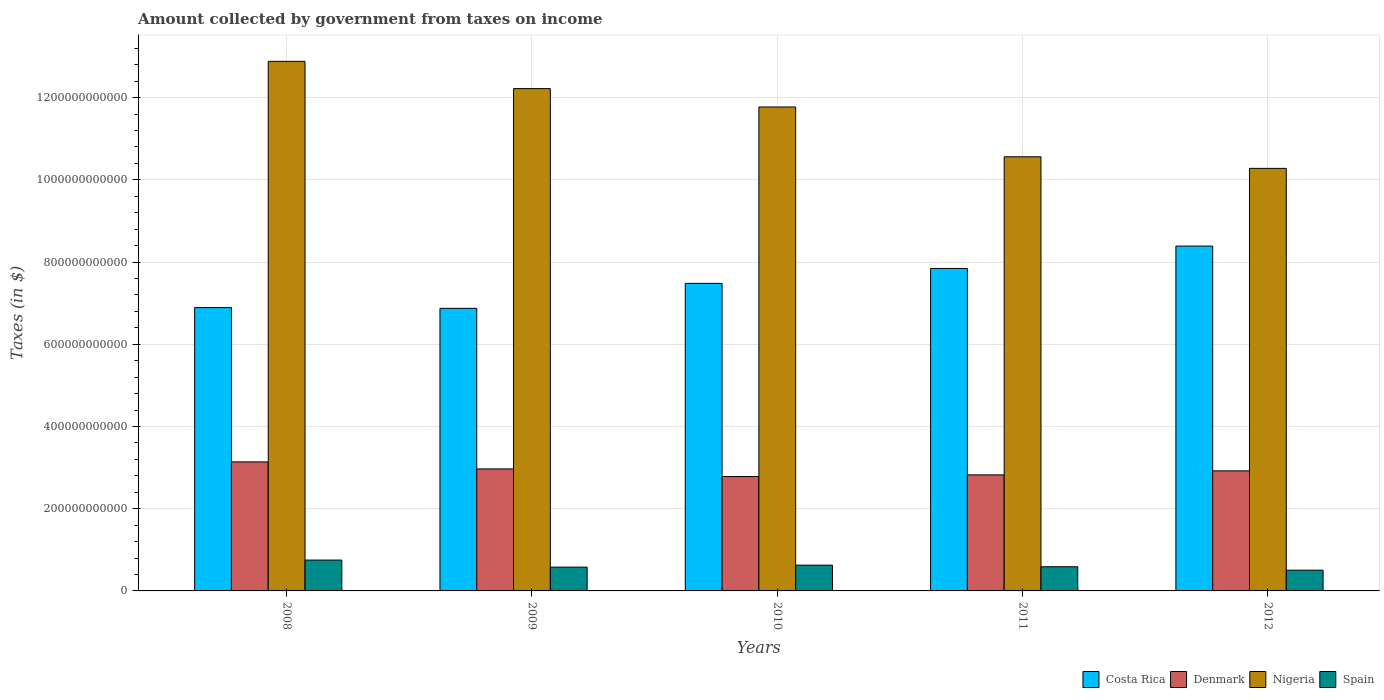How many different coloured bars are there?
Make the answer very short. 4. How many groups of bars are there?
Offer a very short reply. 5. Are the number of bars per tick equal to the number of legend labels?
Make the answer very short. Yes. Are the number of bars on each tick of the X-axis equal?
Your answer should be very brief. Yes. How many bars are there on the 1st tick from the right?
Provide a short and direct response. 4. What is the amount collected by government from taxes on income in Nigeria in 2011?
Make the answer very short. 1.06e+12. Across all years, what is the maximum amount collected by government from taxes on income in Spain?
Provide a succinct answer. 7.50e+1. Across all years, what is the minimum amount collected by government from taxes on income in Nigeria?
Make the answer very short. 1.03e+12. What is the total amount collected by government from taxes on income in Spain in the graph?
Provide a short and direct response. 3.05e+11. What is the difference between the amount collected by government from taxes on income in Nigeria in 2010 and that in 2012?
Your response must be concise. 1.49e+11. What is the difference between the amount collected by government from taxes on income in Denmark in 2008 and the amount collected by government from taxes on income in Spain in 2012?
Ensure brevity in your answer.  2.63e+11. What is the average amount collected by government from taxes on income in Spain per year?
Provide a short and direct response. 6.10e+1. In the year 2012, what is the difference between the amount collected by government from taxes on income in Costa Rica and amount collected by government from taxes on income in Denmark?
Give a very brief answer. 5.47e+11. What is the ratio of the amount collected by government from taxes on income in Nigeria in 2008 to that in 2011?
Offer a terse response. 1.22. Is the amount collected by government from taxes on income in Denmark in 2010 less than that in 2011?
Offer a very short reply. Yes. Is the difference between the amount collected by government from taxes on income in Costa Rica in 2011 and 2012 greater than the difference between the amount collected by government from taxes on income in Denmark in 2011 and 2012?
Make the answer very short. No. What is the difference between the highest and the second highest amount collected by government from taxes on income in Nigeria?
Your answer should be very brief. 6.63e+1. What is the difference between the highest and the lowest amount collected by government from taxes on income in Nigeria?
Keep it short and to the point. 2.60e+11. What does the 3rd bar from the left in 2012 represents?
Give a very brief answer. Nigeria. What does the 3rd bar from the right in 2010 represents?
Give a very brief answer. Denmark. Is it the case that in every year, the sum of the amount collected by government from taxes on income in Nigeria and amount collected by government from taxes on income in Spain is greater than the amount collected by government from taxes on income in Costa Rica?
Provide a succinct answer. Yes. What is the difference between two consecutive major ticks on the Y-axis?
Keep it short and to the point. 2.00e+11. Where does the legend appear in the graph?
Make the answer very short. Bottom right. How many legend labels are there?
Make the answer very short. 4. How are the legend labels stacked?
Make the answer very short. Horizontal. What is the title of the graph?
Offer a very short reply. Amount collected by government from taxes on income. What is the label or title of the X-axis?
Ensure brevity in your answer.  Years. What is the label or title of the Y-axis?
Your answer should be compact. Taxes (in $). What is the Taxes (in $) of Costa Rica in 2008?
Keep it short and to the point. 6.89e+11. What is the Taxes (in $) of Denmark in 2008?
Give a very brief answer. 3.14e+11. What is the Taxes (in $) in Nigeria in 2008?
Keep it short and to the point. 1.29e+12. What is the Taxes (in $) of Spain in 2008?
Provide a short and direct response. 7.50e+1. What is the Taxes (in $) in Costa Rica in 2009?
Your answer should be compact. 6.87e+11. What is the Taxes (in $) of Denmark in 2009?
Your response must be concise. 2.97e+11. What is the Taxes (in $) of Nigeria in 2009?
Give a very brief answer. 1.22e+12. What is the Taxes (in $) of Spain in 2009?
Keep it short and to the point. 5.79e+1. What is the Taxes (in $) of Costa Rica in 2010?
Keep it short and to the point. 7.48e+11. What is the Taxes (in $) in Denmark in 2010?
Your answer should be compact. 2.78e+11. What is the Taxes (in $) of Nigeria in 2010?
Your answer should be very brief. 1.18e+12. What is the Taxes (in $) in Spain in 2010?
Give a very brief answer. 6.27e+1. What is the Taxes (in $) of Costa Rica in 2011?
Your response must be concise. 7.84e+11. What is the Taxes (in $) of Denmark in 2011?
Provide a short and direct response. 2.82e+11. What is the Taxes (in $) in Nigeria in 2011?
Offer a very short reply. 1.06e+12. What is the Taxes (in $) of Spain in 2011?
Your answer should be very brief. 5.88e+1. What is the Taxes (in $) in Costa Rica in 2012?
Offer a very short reply. 8.39e+11. What is the Taxes (in $) in Denmark in 2012?
Provide a short and direct response. 2.92e+11. What is the Taxes (in $) of Nigeria in 2012?
Give a very brief answer. 1.03e+12. What is the Taxes (in $) in Spain in 2012?
Keep it short and to the point. 5.05e+1. Across all years, what is the maximum Taxes (in $) in Costa Rica?
Provide a succinct answer. 8.39e+11. Across all years, what is the maximum Taxes (in $) in Denmark?
Your response must be concise. 3.14e+11. Across all years, what is the maximum Taxes (in $) of Nigeria?
Your response must be concise. 1.29e+12. Across all years, what is the maximum Taxes (in $) in Spain?
Your answer should be compact. 7.50e+1. Across all years, what is the minimum Taxes (in $) in Costa Rica?
Your response must be concise. 6.87e+11. Across all years, what is the minimum Taxes (in $) in Denmark?
Ensure brevity in your answer.  2.78e+11. Across all years, what is the minimum Taxes (in $) of Nigeria?
Offer a very short reply. 1.03e+12. Across all years, what is the minimum Taxes (in $) in Spain?
Ensure brevity in your answer.  5.05e+1. What is the total Taxes (in $) of Costa Rica in the graph?
Keep it short and to the point. 3.75e+12. What is the total Taxes (in $) of Denmark in the graph?
Ensure brevity in your answer.  1.46e+12. What is the total Taxes (in $) in Nigeria in the graph?
Offer a terse response. 5.77e+12. What is the total Taxes (in $) in Spain in the graph?
Your answer should be compact. 3.05e+11. What is the difference between the Taxes (in $) in Costa Rica in 2008 and that in 2009?
Keep it short and to the point. 1.80e+09. What is the difference between the Taxes (in $) in Denmark in 2008 and that in 2009?
Make the answer very short. 1.71e+1. What is the difference between the Taxes (in $) in Nigeria in 2008 and that in 2009?
Provide a short and direct response. 6.63e+1. What is the difference between the Taxes (in $) in Spain in 2008 and that in 2009?
Your response must be concise. 1.71e+1. What is the difference between the Taxes (in $) of Costa Rica in 2008 and that in 2010?
Provide a short and direct response. -5.89e+1. What is the difference between the Taxes (in $) of Denmark in 2008 and that in 2010?
Provide a short and direct response. 3.56e+1. What is the difference between the Taxes (in $) of Nigeria in 2008 and that in 2010?
Your answer should be compact. 1.11e+11. What is the difference between the Taxes (in $) of Spain in 2008 and that in 2010?
Your answer should be very brief. 1.23e+1. What is the difference between the Taxes (in $) of Costa Rica in 2008 and that in 2011?
Ensure brevity in your answer.  -9.52e+1. What is the difference between the Taxes (in $) in Denmark in 2008 and that in 2011?
Keep it short and to the point. 3.16e+1. What is the difference between the Taxes (in $) in Nigeria in 2008 and that in 2011?
Ensure brevity in your answer.  2.32e+11. What is the difference between the Taxes (in $) of Spain in 2008 and that in 2011?
Offer a very short reply. 1.62e+1. What is the difference between the Taxes (in $) of Costa Rica in 2008 and that in 2012?
Keep it short and to the point. -1.50e+11. What is the difference between the Taxes (in $) in Denmark in 2008 and that in 2012?
Your answer should be very brief. 2.18e+1. What is the difference between the Taxes (in $) in Nigeria in 2008 and that in 2012?
Give a very brief answer. 2.60e+11. What is the difference between the Taxes (in $) of Spain in 2008 and that in 2012?
Ensure brevity in your answer.  2.46e+1. What is the difference between the Taxes (in $) of Costa Rica in 2009 and that in 2010?
Your answer should be compact. -6.07e+1. What is the difference between the Taxes (in $) in Denmark in 2009 and that in 2010?
Your answer should be very brief. 1.85e+1. What is the difference between the Taxes (in $) in Nigeria in 2009 and that in 2010?
Your answer should be compact. 4.47e+1. What is the difference between the Taxes (in $) in Spain in 2009 and that in 2010?
Make the answer very short. -4.79e+09. What is the difference between the Taxes (in $) of Costa Rica in 2009 and that in 2011?
Provide a succinct answer. -9.70e+1. What is the difference between the Taxes (in $) in Denmark in 2009 and that in 2011?
Keep it short and to the point. 1.45e+1. What is the difference between the Taxes (in $) of Nigeria in 2009 and that in 2011?
Your response must be concise. 1.66e+11. What is the difference between the Taxes (in $) in Spain in 2009 and that in 2011?
Ensure brevity in your answer.  -8.93e+08. What is the difference between the Taxes (in $) in Costa Rica in 2009 and that in 2012?
Make the answer very short. -1.51e+11. What is the difference between the Taxes (in $) of Denmark in 2009 and that in 2012?
Make the answer very short. 4.66e+09. What is the difference between the Taxes (in $) of Nigeria in 2009 and that in 2012?
Your answer should be very brief. 1.94e+11. What is the difference between the Taxes (in $) in Spain in 2009 and that in 2012?
Provide a short and direct response. 7.44e+09. What is the difference between the Taxes (in $) of Costa Rica in 2010 and that in 2011?
Offer a terse response. -3.63e+1. What is the difference between the Taxes (in $) of Denmark in 2010 and that in 2011?
Ensure brevity in your answer.  -4.02e+09. What is the difference between the Taxes (in $) in Nigeria in 2010 and that in 2011?
Provide a short and direct response. 1.21e+11. What is the difference between the Taxes (in $) in Spain in 2010 and that in 2011?
Ensure brevity in your answer.  3.90e+09. What is the difference between the Taxes (in $) of Costa Rica in 2010 and that in 2012?
Provide a short and direct response. -9.07e+1. What is the difference between the Taxes (in $) in Denmark in 2010 and that in 2012?
Provide a succinct answer. -1.39e+1. What is the difference between the Taxes (in $) of Nigeria in 2010 and that in 2012?
Keep it short and to the point. 1.49e+11. What is the difference between the Taxes (in $) in Spain in 2010 and that in 2012?
Provide a short and direct response. 1.22e+1. What is the difference between the Taxes (in $) in Costa Rica in 2011 and that in 2012?
Provide a succinct answer. -5.44e+1. What is the difference between the Taxes (in $) of Denmark in 2011 and that in 2012?
Ensure brevity in your answer.  -9.83e+09. What is the difference between the Taxes (in $) in Nigeria in 2011 and that in 2012?
Provide a succinct answer. 2.82e+1. What is the difference between the Taxes (in $) in Spain in 2011 and that in 2012?
Give a very brief answer. 8.33e+09. What is the difference between the Taxes (in $) of Costa Rica in 2008 and the Taxes (in $) of Denmark in 2009?
Your response must be concise. 3.92e+11. What is the difference between the Taxes (in $) in Costa Rica in 2008 and the Taxes (in $) in Nigeria in 2009?
Ensure brevity in your answer.  -5.33e+11. What is the difference between the Taxes (in $) of Costa Rica in 2008 and the Taxes (in $) of Spain in 2009?
Offer a very short reply. 6.31e+11. What is the difference between the Taxes (in $) of Denmark in 2008 and the Taxes (in $) of Nigeria in 2009?
Keep it short and to the point. -9.08e+11. What is the difference between the Taxes (in $) of Denmark in 2008 and the Taxes (in $) of Spain in 2009?
Your answer should be very brief. 2.56e+11. What is the difference between the Taxes (in $) in Nigeria in 2008 and the Taxes (in $) in Spain in 2009?
Your answer should be very brief. 1.23e+12. What is the difference between the Taxes (in $) of Costa Rica in 2008 and the Taxes (in $) of Denmark in 2010?
Provide a succinct answer. 4.11e+11. What is the difference between the Taxes (in $) of Costa Rica in 2008 and the Taxes (in $) of Nigeria in 2010?
Provide a succinct answer. -4.88e+11. What is the difference between the Taxes (in $) of Costa Rica in 2008 and the Taxes (in $) of Spain in 2010?
Your answer should be compact. 6.27e+11. What is the difference between the Taxes (in $) in Denmark in 2008 and the Taxes (in $) in Nigeria in 2010?
Provide a succinct answer. -8.63e+11. What is the difference between the Taxes (in $) of Denmark in 2008 and the Taxes (in $) of Spain in 2010?
Provide a short and direct response. 2.51e+11. What is the difference between the Taxes (in $) of Nigeria in 2008 and the Taxes (in $) of Spain in 2010?
Offer a very short reply. 1.23e+12. What is the difference between the Taxes (in $) in Costa Rica in 2008 and the Taxes (in $) in Denmark in 2011?
Offer a very short reply. 4.07e+11. What is the difference between the Taxes (in $) in Costa Rica in 2008 and the Taxes (in $) in Nigeria in 2011?
Offer a very short reply. -3.67e+11. What is the difference between the Taxes (in $) in Costa Rica in 2008 and the Taxes (in $) in Spain in 2011?
Your response must be concise. 6.30e+11. What is the difference between the Taxes (in $) of Denmark in 2008 and the Taxes (in $) of Nigeria in 2011?
Keep it short and to the point. -7.42e+11. What is the difference between the Taxes (in $) in Denmark in 2008 and the Taxes (in $) in Spain in 2011?
Your answer should be very brief. 2.55e+11. What is the difference between the Taxes (in $) in Nigeria in 2008 and the Taxes (in $) in Spain in 2011?
Give a very brief answer. 1.23e+12. What is the difference between the Taxes (in $) of Costa Rica in 2008 and the Taxes (in $) of Denmark in 2012?
Your answer should be very brief. 3.97e+11. What is the difference between the Taxes (in $) in Costa Rica in 2008 and the Taxes (in $) in Nigeria in 2012?
Your response must be concise. -3.39e+11. What is the difference between the Taxes (in $) in Costa Rica in 2008 and the Taxes (in $) in Spain in 2012?
Keep it short and to the point. 6.39e+11. What is the difference between the Taxes (in $) of Denmark in 2008 and the Taxes (in $) of Nigeria in 2012?
Keep it short and to the point. -7.14e+11. What is the difference between the Taxes (in $) in Denmark in 2008 and the Taxes (in $) in Spain in 2012?
Provide a short and direct response. 2.63e+11. What is the difference between the Taxes (in $) in Nigeria in 2008 and the Taxes (in $) in Spain in 2012?
Keep it short and to the point. 1.24e+12. What is the difference between the Taxes (in $) in Costa Rica in 2009 and the Taxes (in $) in Denmark in 2010?
Keep it short and to the point. 4.09e+11. What is the difference between the Taxes (in $) of Costa Rica in 2009 and the Taxes (in $) of Nigeria in 2010?
Your answer should be compact. -4.90e+11. What is the difference between the Taxes (in $) of Costa Rica in 2009 and the Taxes (in $) of Spain in 2010?
Offer a very short reply. 6.25e+11. What is the difference between the Taxes (in $) of Denmark in 2009 and the Taxes (in $) of Nigeria in 2010?
Offer a terse response. -8.80e+11. What is the difference between the Taxes (in $) in Denmark in 2009 and the Taxes (in $) in Spain in 2010?
Keep it short and to the point. 2.34e+11. What is the difference between the Taxes (in $) in Nigeria in 2009 and the Taxes (in $) in Spain in 2010?
Make the answer very short. 1.16e+12. What is the difference between the Taxes (in $) of Costa Rica in 2009 and the Taxes (in $) of Denmark in 2011?
Your answer should be compact. 4.05e+11. What is the difference between the Taxes (in $) of Costa Rica in 2009 and the Taxes (in $) of Nigeria in 2011?
Ensure brevity in your answer.  -3.69e+11. What is the difference between the Taxes (in $) in Costa Rica in 2009 and the Taxes (in $) in Spain in 2011?
Provide a short and direct response. 6.29e+11. What is the difference between the Taxes (in $) in Denmark in 2009 and the Taxes (in $) in Nigeria in 2011?
Provide a succinct answer. -7.59e+11. What is the difference between the Taxes (in $) of Denmark in 2009 and the Taxes (in $) of Spain in 2011?
Offer a very short reply. 2.38e+11. What is the difference between the Taxes (in $) in Nigeria in 2009 and the Taxes (in $) in Spain in 2011?
Provide a succinct answer. 1.16e+12. What is the difference between the Taxes (in $) in Costa Rica in 2009 and the Taxes (in $) in Denmark in 2012?
Your answer should be very brief. 3.95e+11. What is the difference between the Taxes (in $) in Costa Rica in 2009 and the Taxes (in $) in Nigeria in 2012?
Provide a succinct answer. -3.40e+11. What is the difference between the Taxes (in $) of Costa Rica in 2009 and the Taxes (in $) of Spain in 2012?
Your response must be concise. 6.37e+11. What is the difference between the Taxes (in $) in Denmark in 2009 and the Taxes (in $) in Nigeria in 2012?
Offer a terse response. -7.31e+11. What is the difference between the Taxes (in $) in Denmark in 2009 and the Taxes (in $) in Spain in 2012?
Provide a succinct answer. 2.46e+11. What is the difference between the Taxes (in $) of Nigeria in 2009 and the Taxes (in $) of Spain in 2012?
Keep it short and to the point. 1.17e+12. What is the difference between the Taxes (in $) in Costa Rica in 2010 and the Taxes (in $) in Denmark in 2011?
Your answer should be very brief. 4.66e+11. What is the difference between the Taxes (in $) of Costa Rica in 2010 and the Taxes (in $) of Nigeria in 2011?
Your response must be concise. -3.08e+11. What is the difference between the Taxes (in $) in Costa Rica in 2010 and the Taxes (in $) in Spain in 2011?
Provide a succinct answer. 6.89e+11. What is the difference between the Taxes (in $) of Denmark in 2010 and the Taxes (in $) of Nigeria in 2011?
Make the answer very short. -7.78e+11. What is the difference between the Taxes (in $) of Denmark in 2010 and the Taxes (in $) of Spain in 2011?
Give a very brief answer. 2.19e+11. What is the difference between the Taxes (in $) in Nigeria in 2010 and the Taxes (in $) in Spain in 2011?
Give a very brief answer. 1.12e+12. What is the difference between the Taxes (in $) of Costa Rica in 2010 and the Taxes (in $) of Denmark in 2012?
Your response must be concise. 4.56e+11. What is the difference between the Taxes (in $) in Costa Rica in 2010 and the Taxes (in $) in Nigeria in 2012?
Give a very brief answer. -2.80e+11. What is the difference between the Taxes (in $) in Costa Rica in 2010 and the Taxes (in $) in Spain in 2012?
Make the answer very short. 6.98e+11. What is the difference between the Taxes (in $) of Denmark in 2010 and the Taxes (in $) of Nigeria in 2012?
Provide a short and direct response. -7.50e+11. What is the difference between the Taxes (in $) of Denmark in 2010 and the Taxes (in $) of Spain in 2012?
Ensure brevity in your answer.  2.28e+11. What is the difference between the Taxes (in $) in Nigeria in 2010 and the Taxes (in $) in Spain in 2012?
Offer a very short reply. 1.13e+12. What is the difference between the Taxes (in $) of Costa Rica in 2011 and the Taxes (in $) of Denmark in 2012?
Provide a succinct answer. 4.92e+11. What is the difference between the Taxes (in $) of Costa Rica in 2011 and the Taxes (in $) of Nigeria in 2012?
Keep it short and to the point. -2.43e+11. What is the difference between the Taxes (in $) in Costa Rica in 2011 and the Taxes (in $) in Spain in 2012?
Ensure brevity in your answer.  7.34e+11. What is the difference between the Taxes (in $) in Denmark in 2011 and the Taxes (in $) in Nigeria in 2012?
Provide a succinct answer. -7.46e+11. What is the difference between the Taxes (in $) in Denmark in 2011 and the Taxes (in $) in Spain in 2012?
Give a very brief answer. 2.32e+11. What is the difference between the Taxes (in $) in Nigeria in 2011 and the Taxes (in $) in Spain in 2012?
Your answer should be very brief. 1.01e+12. What is the average Taxes (in $) in Costa Rica per year?
Provide a succinct answer. 7.50e+11. What is the average Taxes (in $) of Denmark per year?
Offer a very short reply. 2.93e+11. What is the average Taxes (in $) of Nigeria per year?
Your answer should be very brief. 1.15e+12. What is the average Taxes (in $) in Spain per year?
Provide a short and direct response. 6.10e+1. In the year 2008, what is the difference between the Taxes (in $) in Costa Rica and Taxes (in $) in Denmark?
Make the answer very short. 3.75e+11. In the year 2008, what is the difference between the Taxes (in $) in Costa Rica and Taxes (in $) in Nigeria?
Ensure brevity in your answer.  -5.99e+11. In the year 2008, what is the difference between the Taxes (in $) of Costa Rica and Taxes (in $) of Spain?
Your answer should be compact. 6.14e+11. In the year 2008, what is the difference between the Taxes (in $) in Denmark and Taxes (in $) in Nigeria?
Give a very brief answer. -9.74e+11. In the year 2008, what is the difference between the Taxes (in $) of Denmark and Taxes (in $) of Spain?
Offer a terse response. 2.39e+11. In the year 2008, what is the difference between the Taxes (in $) in Nigeria and Taxes (in $) in Spain?
Offer a very short reply. 1.21e+12. In the year 2009, what is the difference between the Taxes (in $) in Costa Rica and Taxes (in $) in Denmark?
Your answer should be very brief. 3.91e+11. In the year 2009, what is the difference between the Taxes (in $) in Costa Rica and Taxes (in $) in Nigeria?
Your response must be concise. -5.34e+11. In the year 2009, what is the difference between the Taxes (in $) of Costa Rica and Taxes (in $) of Spain?
Ensure brevity in your answer.  6.30e+11. In the year 2009, what is the difference between the Taxes (in $) in Denmark and Taxes (in $) in Nigeria?
Ensure brevity in your answer.  -9.25e+11. In the year 2009, what is the difference between the Taxes (in $) of Denmark and Taxes (in $) of Spain?
Make the answer very short. 2.39e+11. In the year 2009, what is the difference between the Taxes (in $) of Nigeria and Taxes (in $) of Spain?
Ensure brevity in your answer.  1.16e+12. In the year 2010, what is the difference between the Taxes (in $) in Costa Rica and Taxes (in $) in Denmark?
Ensure brevity in your answer.  4.70e+11. In the year 2010, what is the difference between the Taxes (in $) of Costa Rica and Taxes (in $) of Nigeria?
Offer a terse response. -4.29e+11. In the year 2010, what is the difference between the Taxes (in $) of Costa Rica and Taxes (in $) of Spain?
Keep it short and to the point. 6.85e+11. In the year 2010, what is the difference between the Taxes (in $) of Denmark and Taxes (in $) of Nigeria?
Your answer should be compact. -8.99e+11. In the year 2010, what is the difference between the Taxes (in $) in Denmark and Taxes (in $) in Spain?
Provide a short and direct response. 2.16e+11. In the year 2010, what is the difference between the Taxes (in $) in Nigeria and Taxes (in $) in Spain?
Your answer should be very brief. 1.11e+12. In the year 2011, what is the difference between the Taxes (in $) of Costa Rica and Taxes (in $) of Denmark?
Give a very brief answer. 5.02e+11. In the year 2011, what is the difference between the Taxes (in $) in Costa Rica and Taxes (in $) in Nigeria?
Give a very brief answer. -2.72e+11. In the year 2011, what is the difference between the Taxes (in $) of Costa Rica and Taxes (in $) of Spain?
Give a very brief answer. 7.26e+11. In the year 2011, what is the difference between the Taxes (in $) in Denmark and Taxes (in $) in Nigeria?
Give a very brief answer. -7.74e+11. In the year 2011, what is the difference between the Taxes (in $) of Denmark and Taxes (in $) of Spain?
Give a very brief answer. 2.23e+11. In the year 2011, what is the difference between the Taxes (in $) in Nigeria and Taxes (in $) in Spain?
Your answer should be compact. 9.97e+11. In the year 2012, what is the difference between the Taxes (in $) of Costa Rica and Taxes (in $) of Denmark?
Your answer should be compact. 5.47e+11. In the year 2012, what is the difference between the Taxes (in $) of Costa Rica and Taxes (in $) of Nigeria?
Your answer should be very brief. -1.89e+11. In the year 2012, what is the difference between the Taxes (in $) in Costa Rica and Taxes (in $) in Spain?
Give a very brief answer. 7.88e+11. In the year 2012, what is the difference between the Taxes (in $) in Denmark and Taxes (in $) in Nigeria?
Provide a short and direct response. -7.36e+11. In the year 2012, what is the difference between the Taxes (in $) of Denmark and Taxes (in $) of Spain?
Offer a terse response. 2.42e+11. In the year 2012, what is the difference between the Taxes (in $) in Nigeria and Taxes (in $) in Spain?
Ensure brevity in your answer.  9.77e+11. What is the ratio of the Taxes (in $) of Costa Rica in 2008 to that in 2009?
Provide a short and direct response. 1. What is the ratio of the Taxes (in $) of Denmark in 2008 to that in 2009?
Your answer should be compact. 1.06. What is the ratio of the Taxes (in $) in Nigeria in 2008 to that in 2009?
Provide a short and direct response. 1.05. What is the ratio of the Taxes (in $) in Spain in 2008 to that in 2009?
Ensure brevity in your answer.  1.3. What is the ratio of the Taxes (in $) of Costa Rica in 2008 to that in 2010?
Ensure brevity in your answer.  0.92. What is the ratio of the Taxes (in $) in Denmark in 2008 to that in 2010?
Provide a succinct answer. 1.13. What is the ratio of the Taxes (in $) of Nigeria in 2008 to that in 2010?
Keep it short and to the point. 1.09. What is the ratio of the Taxes (in $) of Spain in 2008 to that in 2010?
Provide a short and direct response. 1.2. What is the ratio of the Taxes (in $) in Costa Rica in 2008 to that in 2011?
Your response must be concise. 0.88. What is the ratio of the Taxes (in $) in Denmark in 2008 to that in 2011?
Provide a short and direct response. 1.11. What is the ratio of the Taxes (in $) of Nigeria in 2008 to that in 2011?
Provide a succinct answer. 1.22. What is the ratio of the Taxes (in $) of Spain in 2008 to that in 2011?
Your answer should be compact. 1.28. What is the ratio of the Taxes (in $) in Costa Rica in 2008 to that in 2012?
Ensure brevity in your answer.  0.82. What is the ratio of the Taxes (in $) in Denmark in 2008 to that in 2012?
Offer a terse response. 1.07. What is the ratio of the Taxes (in $) in Nigeria in 2008 to that in 2012?
Your answer should be compact. 1.25. What is the ratio of the Taxes (in $) of Spain in 2008 to that in 2012?
Give a very brief answer. 1.49. What is the ratio of the Taxes (in $) of Costa Rica in 2009 to that in 2010?
Provide a succinct answer. 0.92. What is the ratio of the Taxes (in $) in Denmark in 2009 to that in 2010?
Give a very brief answer. 1.07. What is the ratio of the Taxes (in $) of Nigeria in 2009 to that in 2010?
Give a very brief answer. 1.04. What is the ratio of the Taxes (in $) of Spain in 2009 to that in 2010?
Provide a succinct answer. 0.92. What is the ratio of the Taxes (in $) of Costa Rica in 2009 to that in 2011?
Keep it short and to the point. 0.88. What is the ratio of the Taxes (in $) of Denmark in 2009 to that in 2011?
Offer a terse response. 1.05. What is the ratio of the Taxes (in $) of Nigeria in 2009 to that in 2011?
Keep it short and to the point. 1.16. What is the ratio of the Taxes (in $) of Spain in 2009 to that in 2011?
Provide a short and direct response. 0.98. What is the ratio of the Taxes (in $) in Costa Rica in 2009 to that in 2012?
Provide a short and direct response. 0.82. What is the ratio of the Taxes (in $) of Nigeria in 2009 to that in 2012?
Your answer should be compact. 1.19. What is the ratio of the Taxes (in $) of Spain in 2009 to that in 2012?
Your answer should be very brief. 1.15. What is the ratio of the Taxes (in $) of Costa Rica in 2010 to that in 2011?
Make the answer very short. 0.95. What is the ratio of the Taxes (in $) in Denmark in 2010 to that in 2011?
Give a very brief answer. 0.99. What is the ratio of the Taxes (in $) of Nigeria in 2010 to that in 2011?
Give a very brief answer. 1.11. What is the ratio of the Taxes (in $) in Spain in 2010 to that in 2011?
Your response must be concise. 1.07. What is the ratio of the Taxes (in $) of Costa Rica in 2010 to that in 2012?
Offer a terse response. 0.89. What is the ratio of the Taxes (in $) in Denmark in 2010 to that in 2012?
Your answer should be very brief. 0.95. What is the ratio of the Taxes (in $) in Nigeria in 2010 to that in 2012?
Your answer should be compact. 1.15. What is the ratio of the Taxes (in $) in Spain in 2010 to that in 2012?
Give a very brief answer. 1.24. What is the ratio of the Taxes (in $) of Costa Rica in 2011 to that in 2012?
Make the answer very short. 0.94. What is the ratio of the Taxes (in $) in Denmark in 2011 to that in 2012?
Provide a short and direct response. 0.97. What is the ratio of the Taxes (in $) in Nigeria in 2011 to that in 2012?
Your response must be concise. 1.03. What is the ratio of the Taxes (in $) in Spain in 2011 to that in 2012?
Provide a short and direct response. 1.17. What is the difference between the highest and the second highest Taxes (in $) of Costa Rica?
Keep it short and to the point. 5.44e+1. What is the difference between the highest and the second highest Taxes (in $) in Denmark?
Your response must be concise. 1.71e+1. What is the difference between the highest and the second highest Taxes (in $) in Nigeria?
Give a very brief answer. 6.63e+1. What is the difference between the highest and the second highest Taxes (in $) of Spain?
Your answer should be compact. 1.23e+1. What is the difference between the highest and the lowest Taxes (in $) in Costa Rica?
Your answer should be very brief. 1.51e+11. What is the difference between the highest and the lowest Taxes (in $) in Denmark?
Your answer should be compact. 3.56e+1. What is the difference between the highest and the lowest Taxes (in $) of Nigeria?
Your response must be concise. 2.60e+11. What is the difference between the highest and the lowest Taxes (in $) in Spain?
Provide a succinct answer. 2.46e+1. 